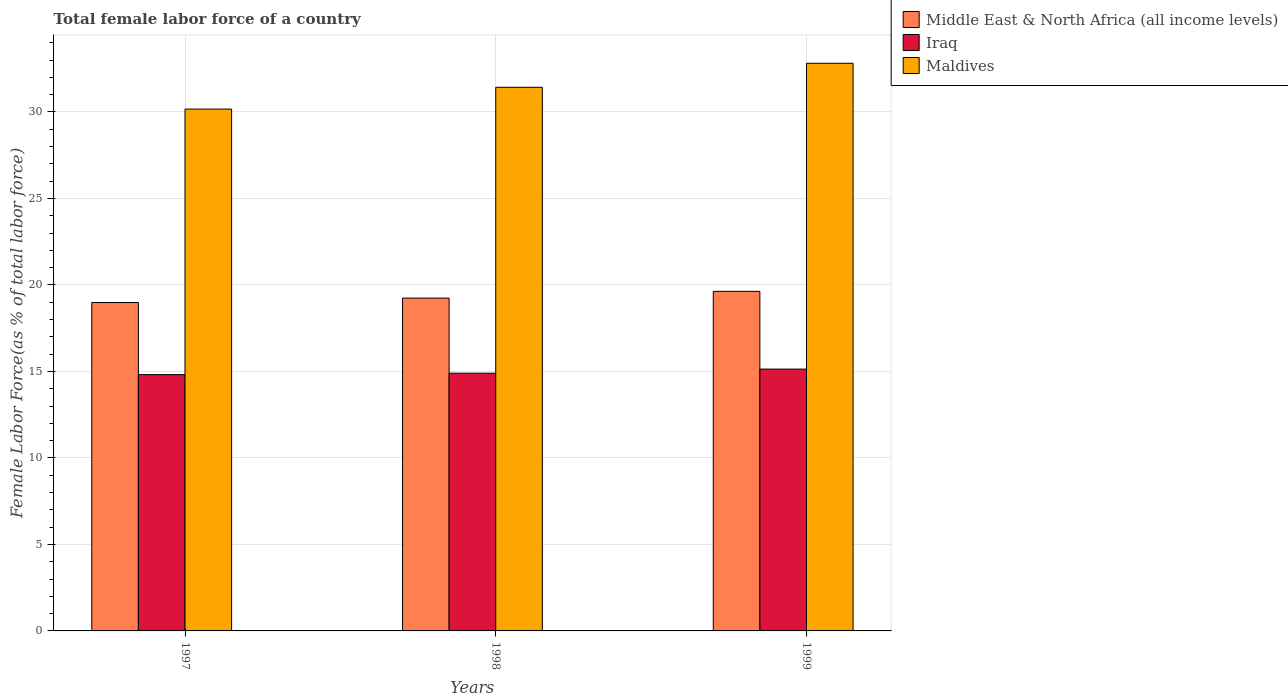How many different coloured bars are there?
Give a very brief answer. 3. In how many cases, is the number of bars for a given year not equal to the number of legend labels?
Offer a very short reply. 0. What is the percentage of female labor force in Iraq in 1997?
Give a very brief answer. 14.81. Across all years, what is the maximum percentage of female labor force in Maldives?
Your answer should be compact. 32.81. Across all years, what is the minimum percentage of female labor force in Iraq?
Your response must be concise. 14.81. In which year was the percentage of female labor force in Middle East & North Africa (all income levels) maximum?
Make the answer very short. 1999. What is the total percentage of female labor force in Maldives in the graph?
Make the answer very short. 94.4. What is the difference between the percentage of female labor force in Iraq in 1997 and that in 1999?
Your answer should be compact. -0.32. What is the difference between the percentage of female labor force in Maldives in 1998 and the percentage of female labor force in Iraq in 1999?
Keep it short and to the point. 16.29. What is the average percentage of female labor force in Iraq per year?
Make the answer very short. 14.95. In the year 1999, what is the difference between the percentage of female labor force in Iraq and percentage of female labor force in Middle East & North Africa (all income levels)?
Keep it short and to the point. -4.49. In how many years, is the percentage of female labor force in Iraq greater than 17 %?
Provide a succinct answer. 0. What is the ratio of the percentage of female labor force in Iraq in 1997 to that in 1998?
Offer a terse response. 0.99. Is the difference between the percentage of female labor force in Iraq in 1998 and 1999 greater than the difference between the percentage of female labor force in Middle East & North Africa (all income levels) in 1998 and 1999?
Keep it short and to the point. Yes. What is the difference between the highest and the second highest percentage of female labor force in Maldives?
Ensure brevity in your answer.  1.39. What is the difference between the highest and the lowest percentage of female labor force in Middle East & North Africa (all income levels)?
Provide a short and direct response. 0.65. In how many years, is the percentage of female labor force in Middle East & North Africa (all income levels) greater than the average percentage of female labor force in Middle East & North Africa (all income levels) taken over all years?
Provide a succinct answer. 1. Is the sum of the percentage of female labor force in Maldives in 1997 and 1998 greater than the maximum percentage of female labor force in Middle East & North Africa (all income levels) across all years?
Your answer should be very brief. Yes. What does the 3rd bar from the left in 1998 represents?
Provide a succinct answer. Maldives. What does the 1st bar from the right in 1997 represents?
Give a very brief answer. Maldives. How many bars are there?
Make the answer very short. 9. What is the difference between two consecutive major ticks on the Y-axis?
Offer a terse response. 5. Are the values on the major ticks of Y-axis written in scientific E-notation?
Offer a very short reply. No. Does the graph contain any zero values?
Your answer should be very brief. No. Does the graph contain grids?
Keep it short and to the point. Yes. What is the title of the graph?
Make the answer very short. Total female labor force of a country. Does "South Africa" appear as one of the legend labels in the graph?
Offer a terse response. No. What is the label or title of the X-axis?
Offer a very short reply. Years. What is the label or title of the Y-axis?
Your response must be concise. Female Labor Force(as % of total labor force). What is the Female Labor Force(as % of total labor force) of Middle East & North Africa (all income levels) in 1997?
Your answer should be compact. 18.98. What is the Female Labor Force(as % of total labor force) of Iraq in 1997?
Make the answer very short. 14.81. What is the Female Labor Force(as % of total labor force) in Maldives in 1997?
Your answer should be very brief. 30.16. What is the Female Labor Force(as % of total labor force) of Middle East & North Africa (all income levels) in 1998?
Provide a succinct answer. 19.24. What is the Female Labor Force(as % of total labor force) of Iraq in 1998?
Make the answer very short. 14.9. What is the Female Labor Force(as % of total labor force) of Maldives in 1998?
Your response must be concise. 31.42. What is the Female Labor Force(as % of total labor force) of Middle East & North Africa (all income levels) in 1999?
Keep it short and to the point. 19.63. What is the Female Labor Force(as % of total labor force) of Iraq in 1999?
Offer a very short reply. 15.13. What is the Female Labor Force(as % of total labor force) in Maldives in 1999?
Provide a short and direct response. 32.81. Across all years, what is the maximum Female Labor Force(as % of total labor force) of Middle East & North Africa (all income levels)?
Provide a short and direct response. 19.63. Across all years, what is the maximum Female Labor Force(as % of total labor force) in Iraq?
Offer a very short reply. 15.13. Across all years, what is the maximum Female Labor Force(as % of total labor force) in Maldives?
Make the answer very short. 32.81. Across all years, what is the minimum Female Labor Force(as % of total labor force) of Middle East & North Africa (all income levels)?
Offer a terse response. 18.98. Across all years, what is the minimum Female Labor Force(as % of total labor force) of Iraq?
Offer a terse response. 14.81. Across all years, what is the minimum Female Labor Force(as % of total labor force) of Maldives?
Your answer should be very brief. 30.16. What is the total Female Labor Force(as % of total labor force) of Middle East & North Africa (all income levels) in the graph?
Make the answer very short. 57.85. What is the total Female Labor Force(as % of total labor force) in Iraq in the graph?
Offer a terse response. 44.85. What is the total Female Labor Force(as % of total labor force) of Maldives in the graph?
Make the answer very short. 94.4. What is the difference between the Female Labor Force(as % of total labor force) of Middle East & North Africa (all income levels) in 1997 and that in 1998?
Give a very brief answer. -0.26. What is the difference between the Female Labor Force(as % of total labor force) of Iraq in 1997 and that in 1998?
Offer a terse response. -0.08. What is the difference between the Female Labor Force(as % of total labor force) in Maldives in 1997 and that in 1998?
Make the answer very short. -1.26. What is the difference between the Female Labor Force(as % of total labor force) in Middle East & North Africa (all income levels) in 1997 and that in 1999?
Keep it short and to the point. -0.65. What is the difference between the Female Labor Force(as % of total labor force) of Iraq in 1997 and that in 1999?
Provide a short and direct response. -0.32. What is the difference between the Female Labor Force(as % of total labor force) in Maldives in 1997 and that in 1999?
Offer a terse response. -2.65. What is the difference between the Female Labor Force(as % of total labor force) in Middle East & North Africa (all income levels) in 1998 and that in 1999?
Give a very brief answer. -0.39. What is the difference between the Female Labor Force(as % of total labor force) of Iraq in 1998 and that in 1999?
Provide a short and direct response. -0.24. What is the difference between the Female Labor Force(as % of total labor force) of Maldives in 1998 and that in 1999?
Make the answer very short. -1.39. What is the difference between the Female Labor Force(as % of total labor force) of Middle East & North Africa (all income levels) in 1997 and the Female Labor Force(as % of total labor force) of Iraq in 1998?
Your response must be concise. 4.09. What is the difference between the Female Labor Force(as % of total labor force) in Middle East & North Africa (all income levels) in 1997 and the Female Labor Force(as % of total labor force) in Maldives in 1998?
Your answer should be compact. -12.44. What is the difference between the Female Labor Force(as % of total labor force) in Iraq in 1997 and the Female Labor Force(as % of total labor force) in Maldives in 1998?
Provide a short and direct response. -16.61. What is the difference between the Female Labor Force(as % of total labor force) of Middle East & North Africa (all income levels) in 1997 and the Female Labor Force(as % of total labor force) of Iraq in 1999?
Give a very brief answer. 3.85. What is the difference between the Female Labor Force(as % of total labor force) of Middle East & North Africa (all income levels) in 1997 and the Female Labor Force(as % of total labor force) of Maldives in 1999?
Your answer should be very brief. -13.83. What is the difference between the Female Labor Force(as % of total labor force) in Iraq in 1997 and the Female Labor Force(as % of total labor force) in Maldives in 1999?
Your response must be concise. -18. What is the difference between the Female Labor Force(as % of total labor force) in Middle East & North Africa (all income levels) in 1998 and the Female Labor Force(as % of total labor force) in Iraq in 1999?
Keep it short and to the point. 4.1. What is the difference between the Female Labor Force(as % of total labor force) in Middle East & North Africa (all income levels) in 1998 and the Female Labor Force(as % of total labor force) in Maldives in 1999?
Provide a short and direct response. -13.57. What is the difference between the Female Labor Force(as % of total labor force) in Iraq in 1998 and the Female Labor Force(as % of total labor force) in Maldives in 1999?
Make the answer very short. -17.92. What is the average Female Labor Force(as % of total labor force) in Middle East & North Africa (all income levels) per year?
Make the answer very short. 19.28. What is the average Female Labor Force(as % of total labor force) of Iraq per year?
Provide a succinct answer. 14.95. What is the average Female Labor Force(as % of total labor force) of Maldives per year?
Give a very brief answer. 31.47. In the year 1997, what is the difference between the Female Labor Force(as % of total labor force) of Middle East & North Africa (all income levels) and Female Labor Force(as % of total labor force) of Iraq?
Keep it short and to the point. 4.17. In the year 1997, what is the difference between the Female Labor Force(as % of total labor force) of Middle East & North Africa (all income levels) and Female Labor Force(as % of total labor force) of Maldives?
Give a very brief answer. -11.18. In the year 1997, what is the difference between the Female Labor Force(as % of total labor force) of Iraq and Female Labor Force(as % of total labor force) of Maldives?
Your answer should be compact. -15.35. In the year 1998, what is the difference between the Female Labor Force(as % of total labor force) in Middle East & North Africa (all income levels) and Female Labor Force(as % of total labor force) in Iraq?
Give a very brief answer. 4.34. In the year 1998, what is the difference between the Female Labor Force(as % of total labor force) in Middle East & North Africa (all income levels) and Female Labor Force(as % of total labor force) in Maldives?
Provide a succinct answer. -12.19. In the year 1998, what is the difference between the Female Labor Force(as % of total labor force) of Iraq and Female Labor Force(as % of total labor force) of Maldives?
Offer a very short reply. -16.53. In the year 1999, what is the difference between the Female Labor Force(as % of total labor force) of Middle East & North Africa (all income levels) and Female Labor Force(as % of total labor force) of Iraq?
Keep it short and to the point. 4.49. In the year 1999, what is the difference between the Female Labor Force(as % of total labor force) in Middle East & North Africa (all income levels) and Female Labor Force(as % of total labor force) in Maldives?
Ensure brevity in your answer.  -13.18. In the year 1999, what is the difference between the Female Labor Force(as % of total labor force) in Iraq and Female Labor Force(as % of total labor force) in Maldives?
Provide a short and direct response. -17.68. What is the ratio of the Female Labor Force(as % of total labor force) in Middle East & North Africa (all income levels) in 1997 to that in 1998?
Make the answer very short. 0.99. What is the ratio of the Female Labor Force(as % of total labor force) in Iraq in 1997 to that in 1998?
Offer a very short reply. 0.99. What is the ratio of the Female Labor Force(as % of total labor force) in Maldives in 1997 to that in 1998?
Your answer should be compact. 0.96. What is the ratio of the Female Labor Force(as % of total labor force) in Middle East & North Africa (all income levels) in 1997 to that in 1999?
Offer a very short reply. 0.97. What is the ratio of the Female Labor Force(as % of total labor force) of Iraq in 1997 to that in 1999?
Offer a very short reply. 0.98. What is the ratio of the Female Labor Force(as % of total labor force) in Maldives in 1997 to that in 1999?
Your response must be concise. 0.92. What is the ratio of the Female Labor Force(as % of total labor force) in Middle East & North Africa (all income levels) in 1998 to that in 1999?
Make the answer very short. 0.98. What is the ratio of the Female Labor Force(as % of total labor force) in Iraq in 1998 to that in 1999?
Offer a very short reply. 0.98. What is the ratio of the Female Labor Force(as % of total labor force) in Maldives in 1998 to that in 1999?
Keep it short and to the point. 0.96. What is the difference between the highest and the second highest Female Labor Force(as % of total labor force) of Middle East & North Africa (all income levels)?
Give a very brief answer. 0.39. What is the difference between the highest and the second highest Female Labor Force(as % of total labor force) of Iraq?
Your answer should be very brief. 0.24. What is the difference between the highest and the second highest Female Labor Force(as % of total labor force) in Maldives?
Your answer should be compact. 1.39. What is the difference between the highest and the lowest Female Labor Force(as % of total labor force) of Middle East & North Africa (all income levels)?
Provide a short and direct response. 0.65. What is the difference between the highest and the lowest Female Labor Force(as % of total labor force) in Iraq?
Give a very brief answer. 0.32. What is the difference between the highest and the lowest Female Labor Force(as % of total labor force) in Maldives?
Ensure brevity in your answer.  2.65. 